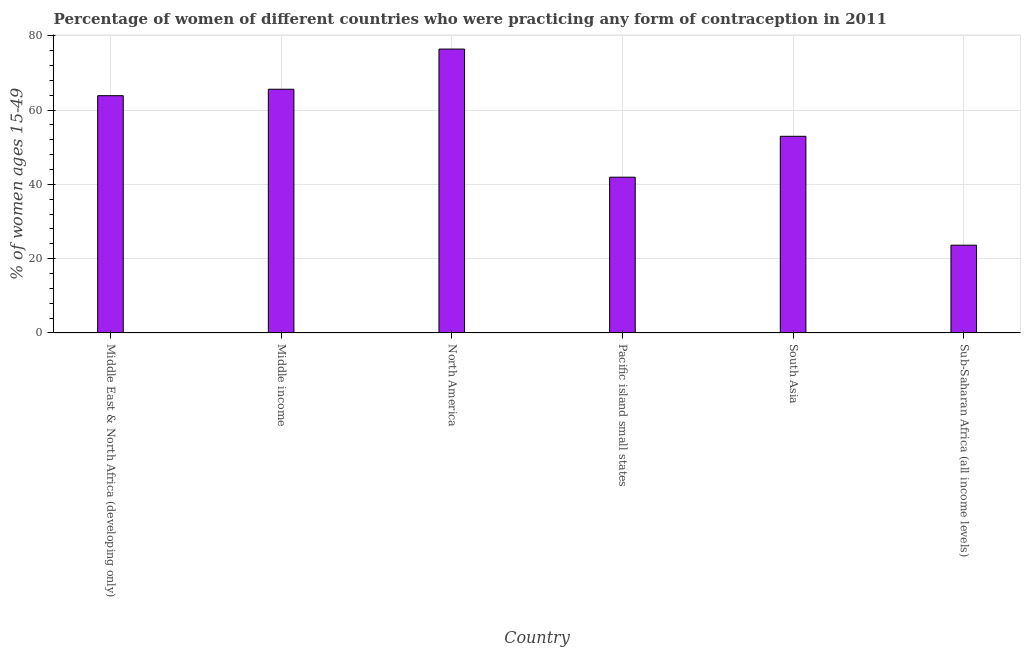Does the graph contain any zero values?
Provide a short and direct response. No. What is the title of the graph?
Offer a very short reply. Percentage of women of different countries who were practicing any form of contraception in 2011. What is the label or title of the Y-axis?
Keep it short and to the point. % of women ages 15-49. What is the contraceptive prevalence in Middle income?
Provide a short and direct response. 65.59. Across all countries, what is the maximum contraceptive prevalence?
Make the answer very short. 76.4. Across all countries, what is the minimum contraceptive prevalence?
Make the answer very short. 23.61. In which country was the contraceptive prevalence minimum?
Your answer should be compact. Sub-Saharan Africa (all income levels). What is the sum of the contraceptive prevalence?
Make the answer very short. 324.29. What is the difference between the contraceptive prevalence in Pacific island small states and South Asia?
Offer a very short reply. -11. What is the average contraceptive prevalence per country?
Offer a very short reply. 54.05. What is the median contraceptive prevalence?
Provide a short and direct response. 58.39. What is the ratio of the contraceptive prevalence in Middle East & North Africa (developing only) to that in North America?
Give a very brief answer. 0.84. Is the contraceptive prevalence in Middle income less than that in South Asia?
Offer a terse response. No. What is the difference between the highest and the second highest contraceptive prevalence?
Make the answer very short. 10.81. Is the sum of the contraceptive prevalence in Pacific island small states and Sub-Saharan Africa (all income levels) greater than the maximum contraceptive prevalence across all countries?
Provide a short and direct response. No. What is the difference between the highest and the lowest contraceptive prevalence?
Ensure brevity in your answer.  52.79. How many bars are there?
Provide a succinct answer. 6. Are all the bars in the graph horizontal?
Ensure brevity in your answer.  No. What is the difference between two consecutive major ticks on the Y-axis?
Offer a terse response. 20. Are the values on the major ticks of Y-axis written in scientific E-notation?
Keep it short and to the point. No. What is the % of women ages 15-49 of Middle East & North Africa (developing only)?
Offer a very short reply. 63.86. What is the % of women ages 15-49 in Middle income?
Your response must be concise. 65.59. What is the % of women ages 15-49 of North America?
Your answer should be compact. 76.4. What is the % of women ages 15-49 in Pacific island small states?
Your answer should be compact. 41.92. What is the % of women ages 15-49 of South Asia?
Your response must be concise. 52.92. What is the % of women ages 15-49 of Sub-Saharan Africa (all income levels)?
Your response must be concise. 23.61. What is the difference between the % of women ages 15-49 in Middle East & North Africa (developing only) and Middle income?
Your answer should be very brief. -1.73. What is the difference between the % of women ages 15-49 in Middle East & North Africa (developing only) and North America?
Give a very brief answer. -12.54. What is the difference between the % of women ages 15-49 in Middle East & North Africa (developing only) and Pacific island small states?
Your answer should be compact. 21.94. What is the difference between the % of women ages 15-49 in Middle East & North Africa (developing only) and South Asia?
Keep it short and to the point. 10.94. What is the difference between the % of women ages 15-49 in Middle East & North Africa (developing only) and Sub-Saharan Africa (all income levels)?
Give a very brief answer. 40.24. What is the difference between the % of women ages 15-49 in Middle income and North America?
Your response must be concise. -10.81. What is the difference between the % of women ages 15-49 in Middle income and Pacific island small states?
Your answer should be compact. 23.67. What is the difference between the % of women ages 15-49 in Middle income and South Asia?
Your response must be concise. 12.67. What is the difference between the % of women ages 15-49 in Middle income and Sub-Saharan Africa (all income levels)?
Give a very brief answer. 41.97. What is the difference between the % of women ages 15-49 in North America and Pacific island small states?
Ensure brevity in your answer.  34.48. What is the difference between the % of women ages 15-49 in North America and South Asia?
Make the answer very short. 23.48. What is the difference between the % of women ages 15-49 in North America and Sub-Saharan Africa (all income levels)?
Your answer should be compact. 52.79. What is the difference between the % of women ages 15-49 in Pacific island small states and South Asia?
Your response must be concise. -11. What is the difference between the % of women ages 15-49 in Pacific island small states and Sub-Saharan Africa (all income levels)?
Offer a terse response. 18.3. What is the difference between the % of women ages 15-49 in South Asia and Sub-Saharan Africa (all income levels)?
Your response must be concise. 29.31. What is the ratio of the % of women ages 15-49 in Middle East & North Africa (developing only) to that in North America?
Offer a very short reply. 0.84. What is the ratio of the % of women ages 15-49 in Middle East & North Africa (developing only) to that in Pacific island small states?
Provide a succinct answer. 1.52. What is the ratio of the % of women ages 15-49 in Middle East & North Africa (developing only) to that in South Asia?
Keep it short and to the point. 1.21. What is the ratio of the % of women ages 15-49 in Middle East & North Africa (developing only) to that in Sub-Saharan Africa (all income levels)?
Provide a short and direct response. 2.7. What is the ratio of the % of women ages 15-49 in Middle income to that in North America?
Make the answer very short. 0.86. What is the ratio of the % of women ages 15-49 in Middle income to that in Pacific island small states?
Your response must be concise. 1.56. What is the ratio of the % of women ages 15-49 in Middle income to that in South Asia?
Your response must be concise. 1.24. What is the ratio of the % of women ages 15-49 in Middle income to that in Sub-Saharan Africa (all income levels)?
Provide a short and direct response. 2.78. What is the ratio of the % of women ages 15-49 in North America to that in Pacific island small states?
Your answer should be compact. 1.82. What is the ratio of the % of women ages 15-49 in North America to that in South Asia?
Provide a short and direct response. 1.44. What is the ratio of the % of women ages 15-49 in North America to that in Sub-Saharan Africa (all income levels)?
Provide a short and direct response. 3.23. What is the ratio of the % of women ages 15-49 in Pacific island small states to that in South Asia?
Your answer should be compact. 0.79. What is the ratio of the % of women ages 15-49 in Pacific island small states to that in Sub-Saharan Africa (all income levels)?
Make the answer very short. 1.77. What is the ratio of the % of women ages 15-49 in South Asia to that in Sub-Saharan Africa (all income levels)?
Provide a short and direct response. 2.24. 